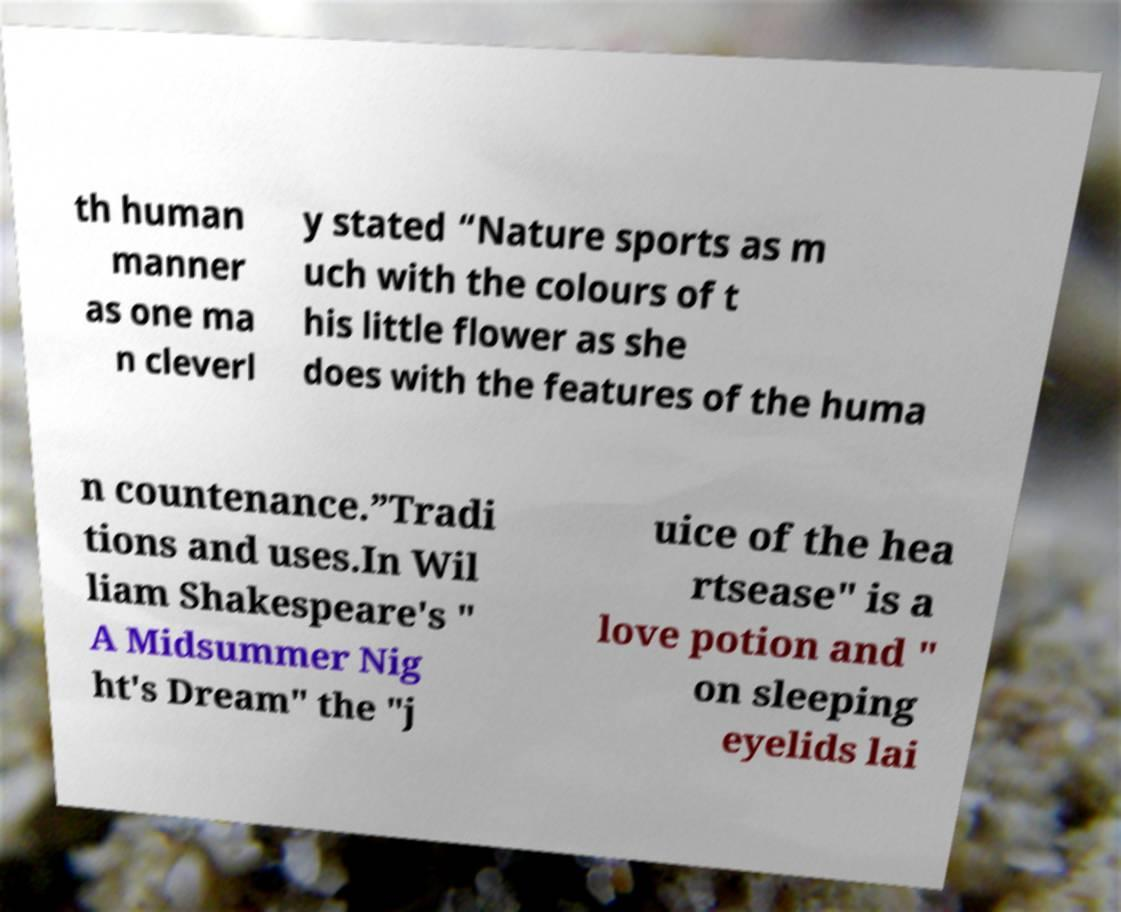For documentation purposes, I need the text within this image transcribed. Could you provide that? th human manner as one ma n cleverl y stated “Nature sports as m uch with the colours of t his little flower as she does with the features of the huma n countenance.”Tradi tions and uses.In Wil liam Shakespeare's " A Midsummer Nig ht's Dream" the "j uice of the hea rtsease" is a love potion and " on sleeping eyelids lai 